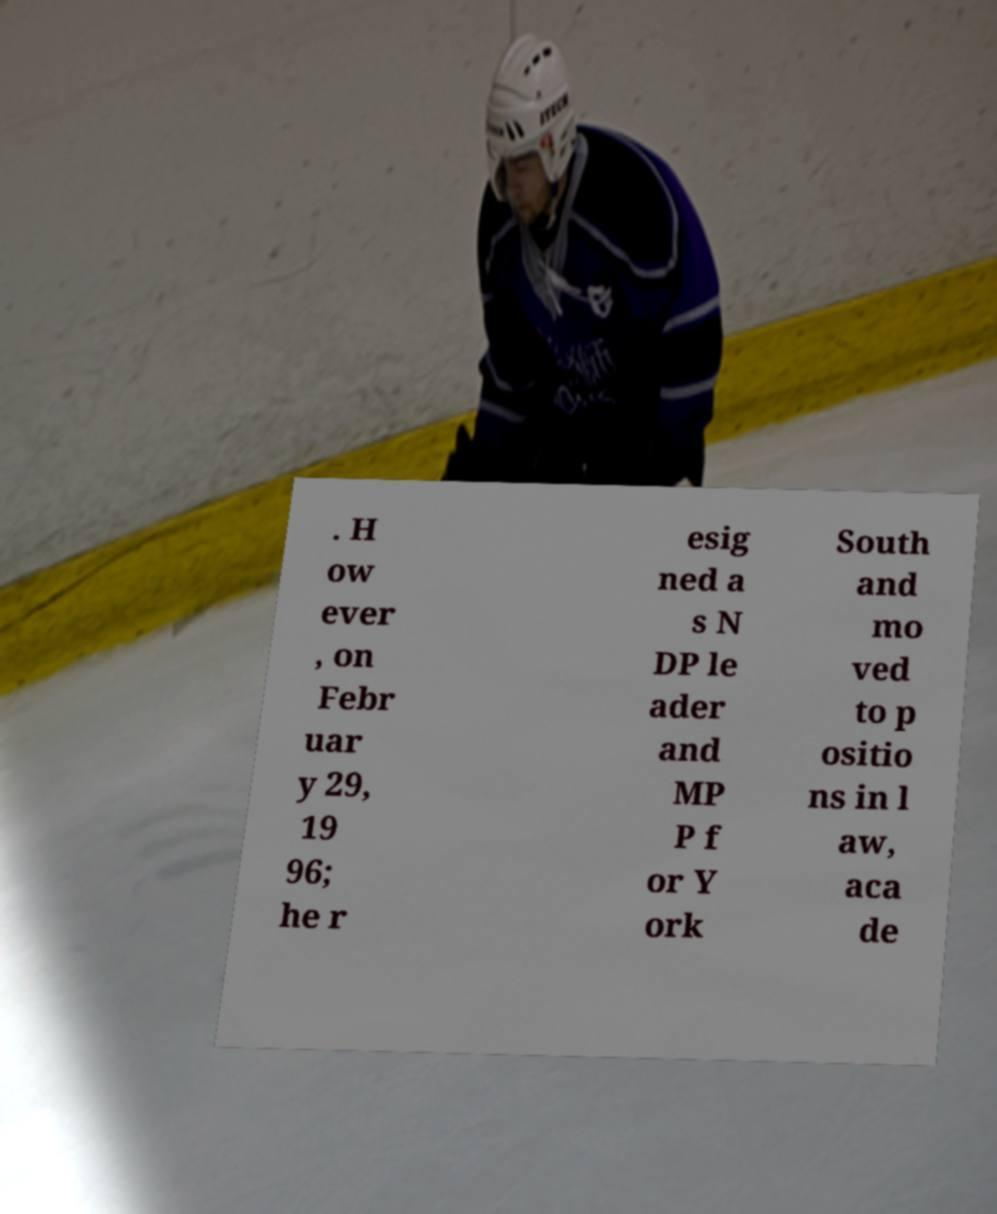There's text embedded in this image that I need extracted. Can you transcribe it verbatim? . H ow ever , on Febr uar y 29, 19 96; he r esig ned a s N DP le ader and MP P f or Y ork South and mo ved to p ositio ns in l aw, aca de 